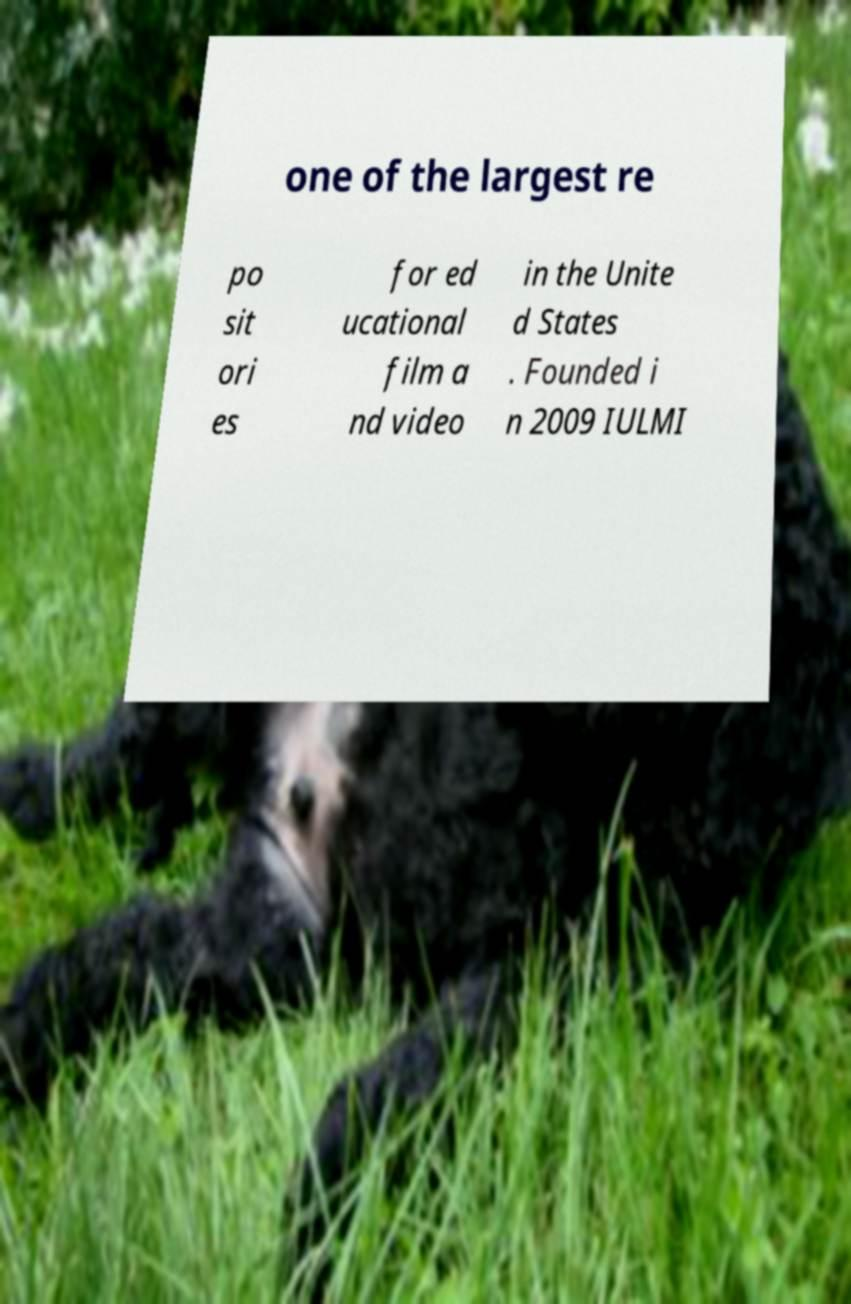Can you read and provide the text displayed in the image?This photo seems to have some interesting text. Can you extract and type it out for me? one of the largest re po sit ori es for ed ucational film a nd video in the Unite d States . Founded i n 2009 IULMI 